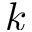Convert formula to latex. <formula><loc_0><loc_0><loc_500><loc_500>k</formula> 